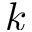Convert formula to latex. <formula><loc_0><loc_0><loc_500><loc_500>k</formula> 